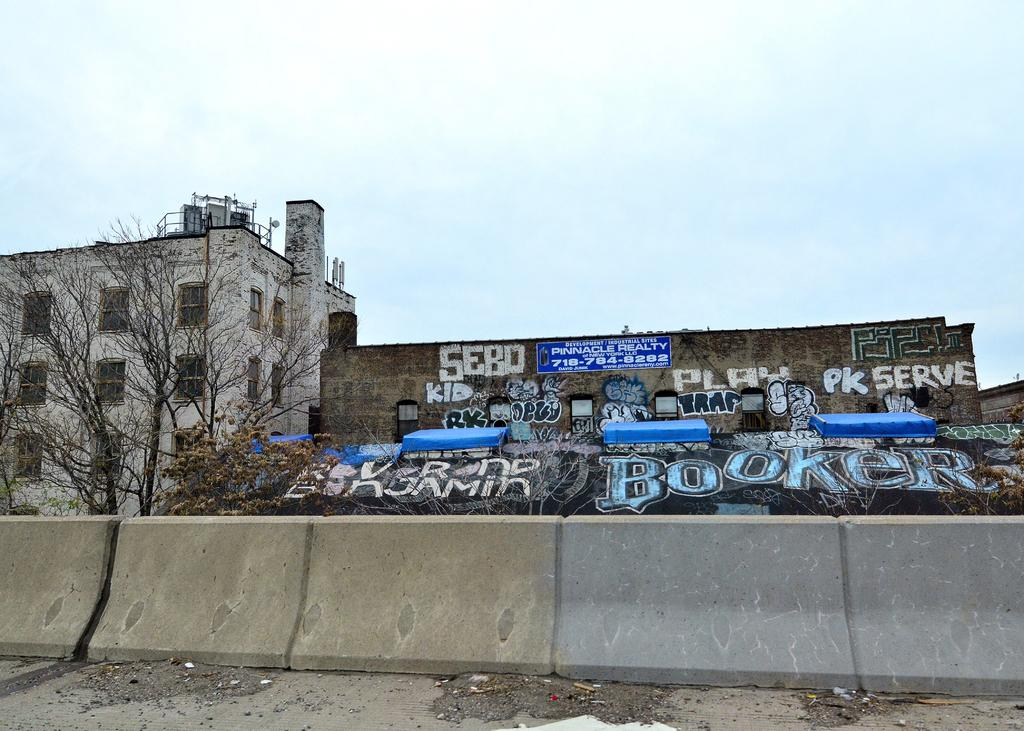What is present in the foreground of the image? There is a wall in the image. What can be seen in the background of the image? There are trees and a building in the background of the image. Can you describe the text on one of the buildings? Yes, there is text on one of the buildings in the image. What is visible in the sky in the image? The sky is visible in the image. Can you see a maid cleaning the marble floor in the image? There is no maid or marble floor present in the image. What type of plane is flying in the sky in the image? There is no plane visible in the sky in the image. 